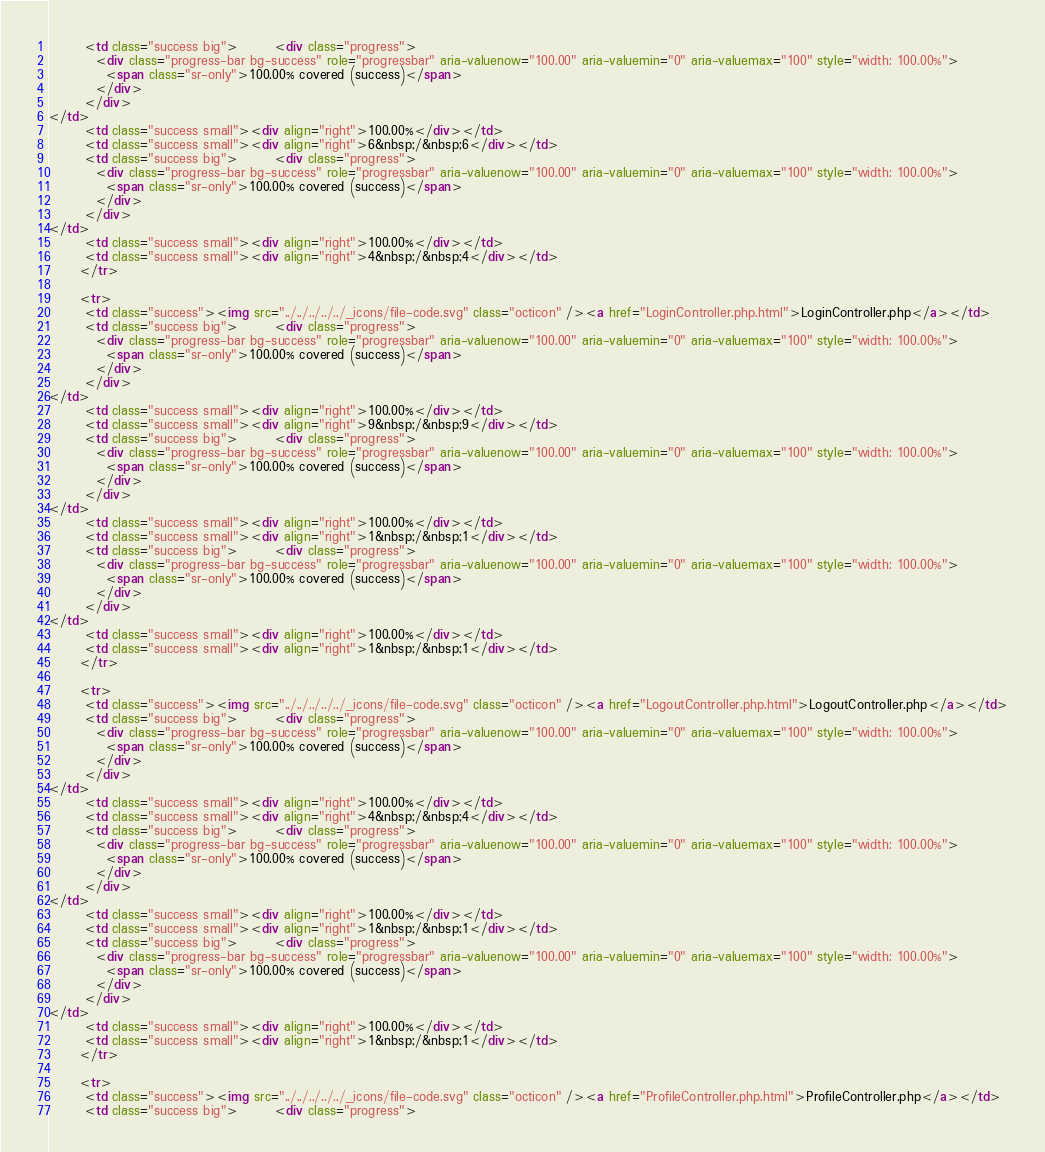<code> <loc_0><loc_0><loc_500><loc_500><_HTML_>       <td class="success big">       <div class="progress">
         <div class="progress-bar bg-success" role="progressbar" aria-valuenow="100.00" aria-valuemin="0" aria-valuemax="100" style="width: 100.00%">
           <span class="sr-only">100.00% covered (success)</span>
         </div>
       </div>
</td>
       <td class="success small"><div align="right">100.00%</div></td>
       <td class="success small"><div align="right">6&nbsp;/&nbsp;6</div></td>
       <td class="success big">       <div class="progress">
         <div class="progress-bar bg-success" role="progressbar" aria-valuenow="100.00" aria-valuemin="0" aria-valuemax="100" style="width: 100.00%">
           <span class="sr-only">100.00% covered (success)</span>
         </div>
       </div>
</td>
       <td class="success small"><div align="right">100.00%</div></td>
       <td class="success small"><div align="right">4&nbsp;/&nbsp;4</div></td>
      </tr>

      <tr>
       <td class="success"><img src="../../../../../_icons/file-code.svg" class="octicon" /><a href="LoginController.php.html">LoginController.php</a></td>
       <td class="success big">       <div class="progress">
         <div class="progress-bar bg-success" role="progressbar" aria-valuenow="100.00" aria-valuemin="0" aria-valuemax="100" style="width: 100.00%">
           <span class="sr-only">100.00% covered (success)</span>
         </div>
       </div>
</td>
       <td class="success small"><div align="right">100.00%</div></td>
       <td class="success small"><div align="right">9&nbsp;/&nbsp;9</div></td>
       <td class="success big">       <div class="progress">
         <div class="progress-bar bg-success" role="progressbar" aria-valuenow="100.00" aria-valuemin="0" aria-valuemax="100" style="width: 100.00%">
           <span class="sr-only">100.00% covered (success)</span>
         </div>
       </div>
</td>
       <td class="success small"><div align="right">100.00%</div></td>
       <td class="success small"><div align="right">1&nbsp;/&nbsp;1</div></td>
       <td class="success big">       <div class="progress">
         <div class="progress-bar bg-success" role="progressbar" aria-valuenow="100.00" aria-valuemin="0" aria-valuemax="100" style="width: 100.00%">
           <span class="sr-only">100.00% covered (success)</span>
         </div>
       </div>
</td>
       <td class="success small"><div align="right">100.00%</div></td>
       <td class="success small"><div align="right">1&nbsp;/&nbsp;1</div></td>
      </tr>

      <tr>
       <td class="success"><img src="../../../../../_icons/file-code.svg" class="octicon" /><a href="LogoutController.php.html">LogoutController.php</a></td>
       <td class="success big">       <div class="progress">
         <div class="progress-bar bg-success" role="progressbar" aria-valuenow="100.00" aria-valuemin="0" aria-valuemax="100" style="width: 100.00%">
           <span class="sr-only">100.00% covered (success)</span>
         </div>
       </div>
</td>
       <td class="success small"><div align="right">100.00%</div></td>
       <td class="success small"><div align="right">4&nbsp;/&nbsp;4</div></td>
       <td class="success big">       <div class="progress">
         <div class="progress-bar bg-success" role="progressbar" aria-valuenow="100.00" aria-valuemin="0" aria-valuemax="100" style="width: 100.00%">
           <span class="sr-only">100.00% covered (success)</span>
         </div>
       </div>
</td>
       <td class="success small"><div align="right">100.00%</div></td>
       <td class="success small"><div align="right">1&nbsp;/&nbsp;1</div></td>
       <td class="success big">       <div class="progress">
         <div class="progress-bar bg-success" role="progressbar" aria-valuenow="100.00" aria-valuemin="0" aria-valuemax="100" style="width: 100.00%">
           <span class="sr-only">100.00% covered (success)</span>
         </div>
       </div>
</td>
       <td class="success small"><div align="right">100.00%</div></td>
       <td class="success small"><div align="right">1&nbsp;/&nbsp;1</div></td>
      </tr>

      <tr>
       <td class="success"><img src="../../../../../_icons/file-code.svg" class="octicon" /><a href="ProfileController.php.html">ProfileController.php</a></td>
       <td class="success big">       <div class="progress"></code> 